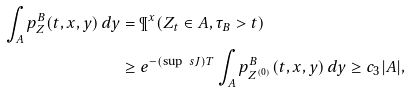Convert formula to latex. <formula><loc_0><loc_0><loc_500><loc_500>\int _ { A } p ^ { B } _ { Z } ( t , x , y ) \, d y & = \P ^ { x } ( Z _ { t } \in A , \tau _ { B } > t ) \\ & \geq e ^ { - ( \sup \ s J ) T } \int _ { A } p ^ { B } _ { Z ^ { ( 0 ) } } ( t , x , y ) \, d y \geq c _ { 3 } | A | ,</formula> 